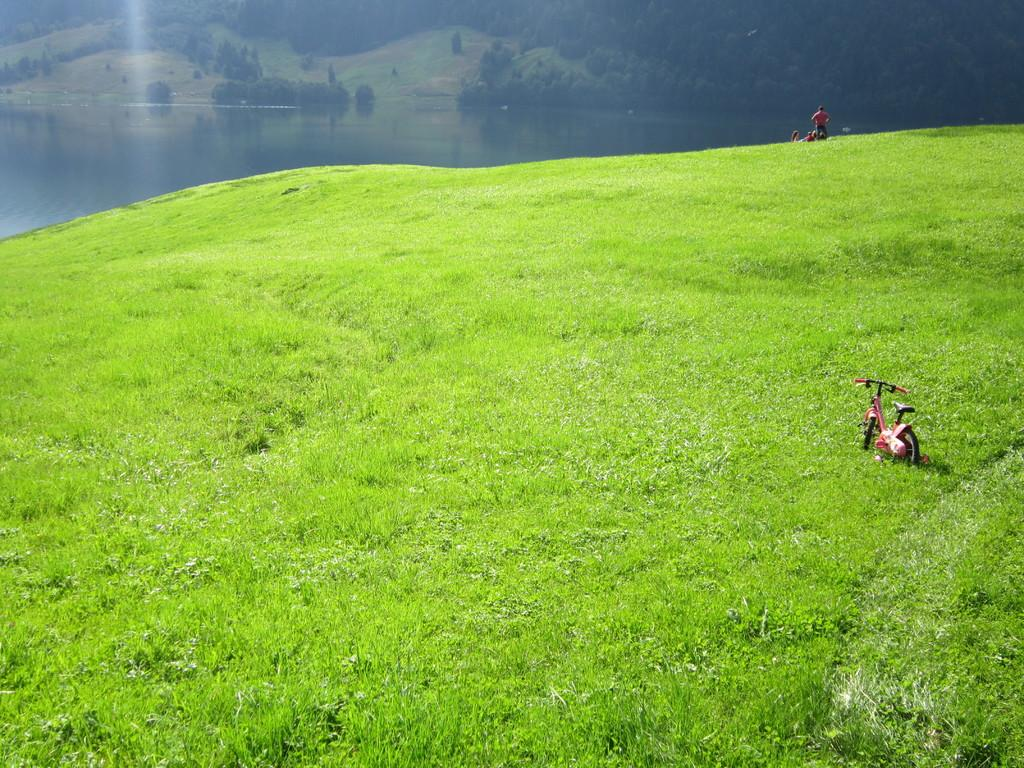What is the main subject in the image? There is a vehicle in the image. Can you describe the person in the image? There is a person in the image, and they are on the grass. What type of natural environment is visible in the image? There are trees and water visible in the image. What note is the person playing on their ear in the image? There is no person playing a note on their ear in the image; the person is simply lying on the grass. 